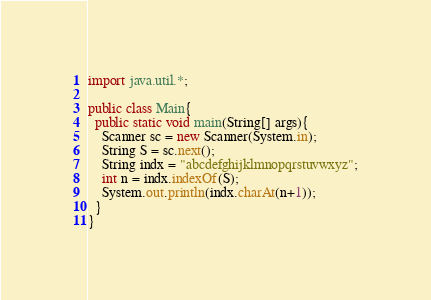<code> <loc_0><loc_0><loc_500><loc_500><_Java_>import java.util.*;

public class Main{
  public static void main(String[] args){
    Scanner sc = new Scanner(System.in);
    String S = sc.next();
    String indx = "abcdefghijklmnopqrstuvwxyz";
    int n = indx.indexOf(S);
    System.out.println(indx.charAt(n+1));
  }
}</code> 